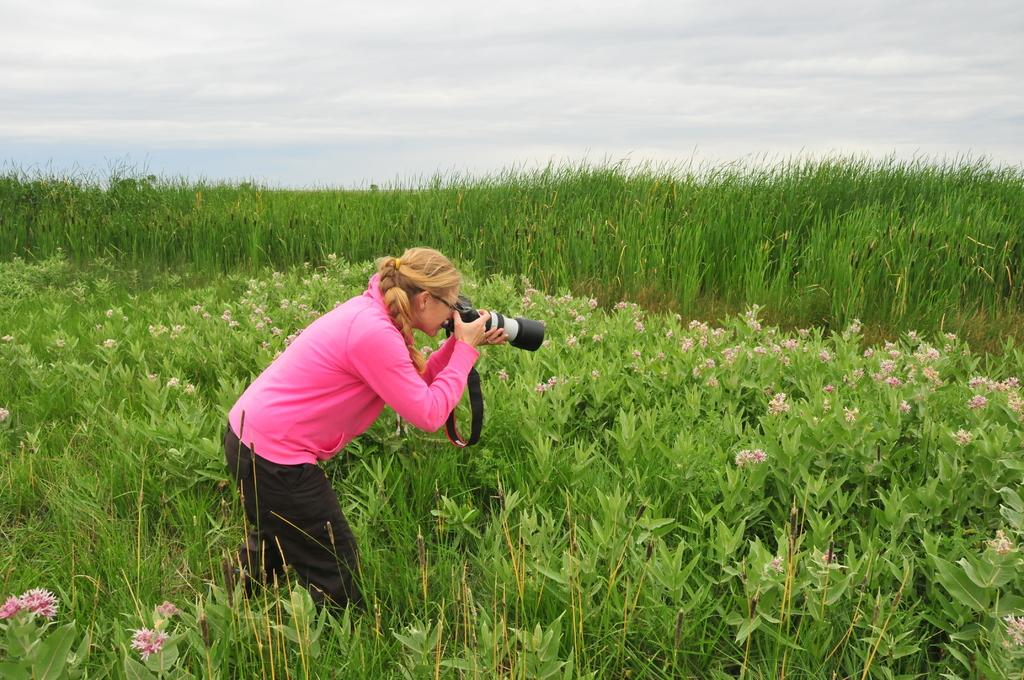What is the main subject of the image? There is a person standing in the middle of the image. What is the person holding in the image? The person is holding a camera. What type of vegetation can be seen behind the person? There are plants behind the person. What is the ground made of in the image? There is grass visible in the image. What can be seen in the sky in the image? There are clouds at the top of the image, and the sky is visible. What type of alarm can be heard going off in the image? There is no alarm present in the image, and therefore no sound can be heard. 